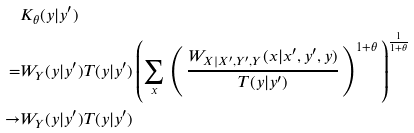Convert formula to latex. <formula><loc_0><loc_0><loc_500><loc_500>& K _ { \theta } ( y | y ^ { \prime } ) \\ = & W _ { Y } ( y | y ^ { \prime } ) T ( y | y ^ { \prime } ) \left ( \sum _ { x } \, \left ( \, \frac { W _ { X | X ^ { \prime } , Y ^ { \prime } , Y } ( x | x ^ { \prime } , y ^ { \prime } , y ) } { T ( y | y ^ { \prime } ) } \, \right ) ^ { 1 + \theta } \, \right ) ^ { \frac { 1 } { 1 + \theta } } \\ \to & W _ { Y } ( y | y ^ { \prime } ) T ( y | y ^ { \prime } )</formula> 